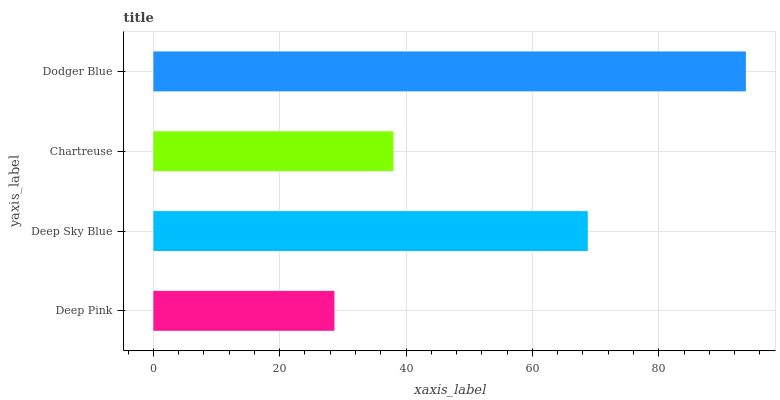Is Deep Pink the minimum?
Answer yes or no. Yes. Is Dodger Blue the maximum?
Answer yes or no. Yes. Is Deep Sky Blue the minimum?
Answer yes or no. No. Is Deep Sky Blue the maximum?
Answer yes or no. No. Is Deep Sky Blue greater than Deep Pink?
Answer yes or no. Yes. Is Deep Pink less than Deep Sky Blue?
Answer yes or no. Yes. Is Deep Pink greater than Deep Sky Blue?
Answer yes or no. No. Is Deep Sky Blue less than Deep Pink?
Answer yes or no. No. Is Deep Sky Blue the high median?
Answer yes or no. Yes. Is Chartreuse the low median?
Answer yes or no. Yes. Is Dodger Blue the high median?
Answer yes or no. No. Is Deep Sky Blue the low median?
Answer yes or no. No. 